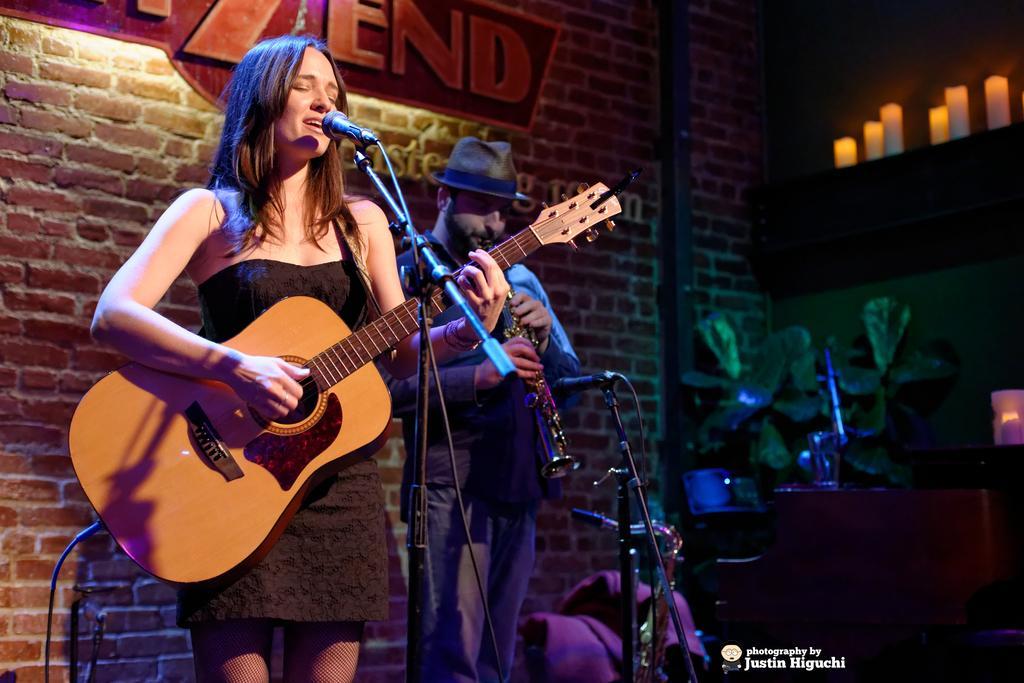Can you describe this image briefly? In the image we can see there is a woman who is standing and holding guitar in her hand and beside him there is a person who is standing and holding musical instrument in his hand. He is wearing a cap and at the back the wall is made up of red bricks. 